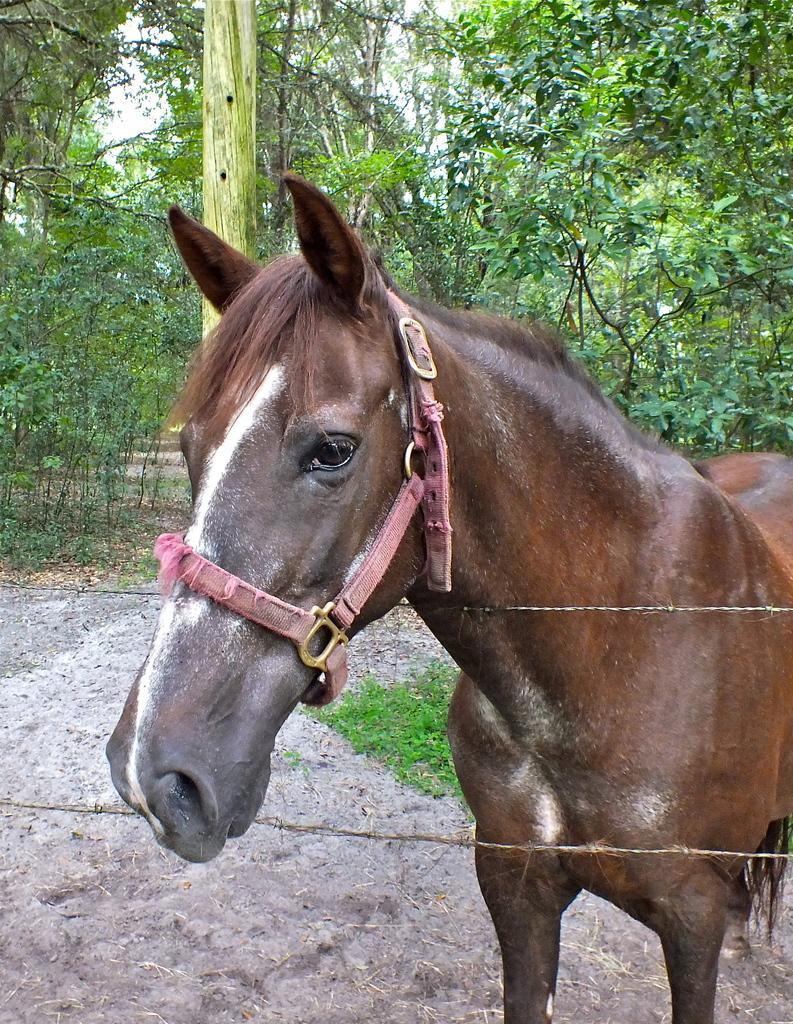How would you summarize this image in a sentence or two? In this image we can see a horse near the wire fence. In the background, we can see the grass, wooden pole and the trees. 